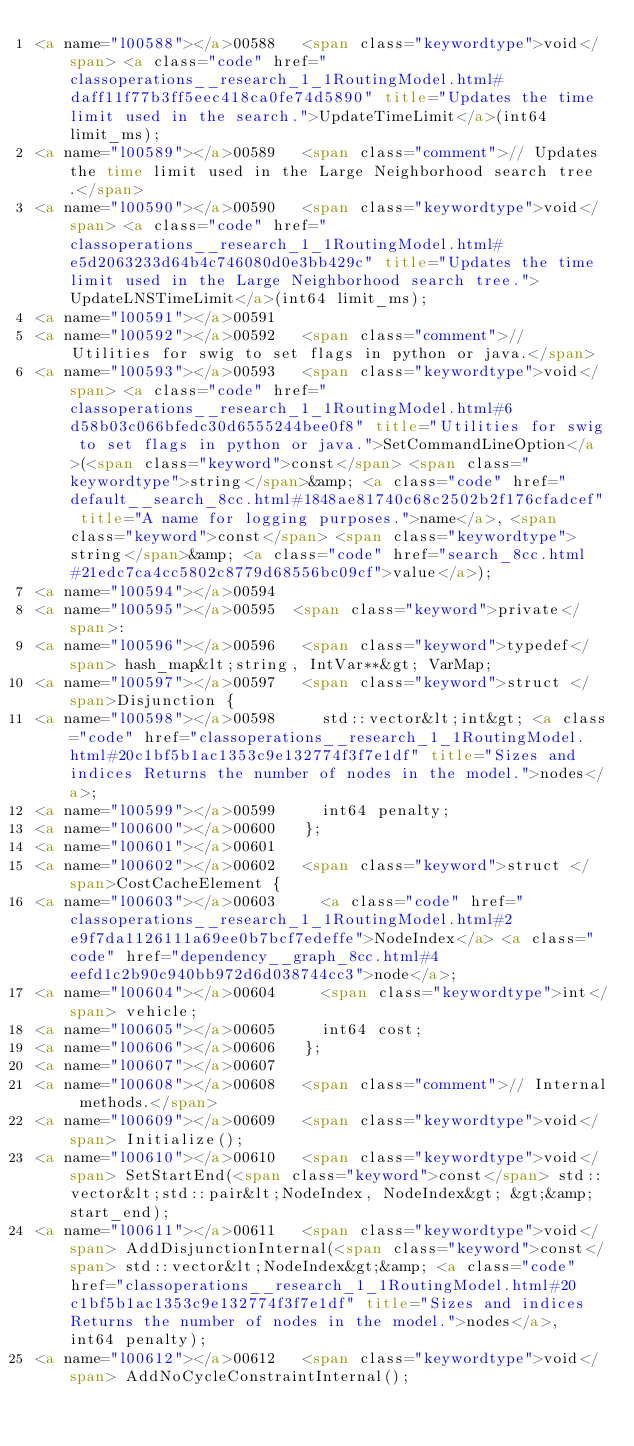Convert code to text. <code><loc_0><loc_0><loc_500><loc_500><_HTML_><a name="l00588"></a>00588   <span class="keywordtype">void</span> <a class="code" href="classoperations__research_1_1RoutingModel.html#daff11f77b3ff5eec418ca0fe74d5890" title="Updates the time limit used in the search.">UpdateTimeLimit</a>(int64 limit_ms);
<a name="l00589"></a>00589   <span class="comment">// Updates the time limit used in the Large Neighborhood search tree.</span>
<a name="l00590"></a>00590   <span class="keywordtype">void</span> <a class="code" href="classoperations__research_1_1RoutingModel.html#e5d2063233d64b4c746080d0e3bb429c" title="Updates the time limit used in the Large Neighborhood search tree.">UpdateLNSTimeLimit</a>(int64 limit_ms);
<a name="l00591"></a>00591 
<a name="l00592"></a>00592   <span class="comment">// Utilities for swig to set flags in python or java.</span>
<a name="l00593"></a>00593   <span class="keywordtype">void</span> <a class="code" href="classoperations__research_1_1RoutingModel.html#6d58b03c066bfedc30d6555244bee0f8" title="Utilities for swig to set flags in python or java.">SetCommandLineOption</a>(<span class="keyword">const</span> <span class="keywordtype">string</span>&amp; <a class="code" href="default__search_8cc.html#1848ae81740c68c2502b2f176cfadcef" title="A name for logging purposes.">name</a>, <span class="keyword">const</span> <span class="keywordtype">string</span>&amp; <a class="code" href="search_8cc.html#21edc7ca4cc5802c8779d68556bc09cf">value</a>);
<a name="l00594"></a>00594 
<a name="l00595"></a>00595  <span class="keyword">private</span>:
<a name="l00596"></a>00596   <span class="keyword">typedef</span> hash_map&lt;string, IntVar**&gt; VarMap;
<a name="l00597"></a>00597   <span class="keyword">struct </span>Disjunction {
<a name="l00598"></a>00598     std::vector&lt;int&gt; <a class="code" href="classoperations__research_1_1RoutingModel.html#20c1bf5b1ac1353c9e132774f3f7e1df" title="Sizes and indices Returns the number of nodes in the model.">nodes</a>;
<a name="l00599"></a>00599     int64 penalty;
<a name="l00600"></a>00600   };
<a name="l00601"></a>00601 
<a name="l00602"></a>00602   <span class="keyword">struct </span>CostCacheElement {
<a name="l00603"></a>00603     <a class="code" href="classoperations__research_1_1RoutingModel.html#2e9f7da1126111a69ee0b7bcf7edeffe">NodeIndex</a> <a class="code" href="dependency__graph_8cc.html#4eefd1c2b90c940bb972d6d038744cc3">node</a>;
<a name="l00604"></a>00604     <span class="keywordtype">int</span> vehicle;
<a name="l00605"></a>00605     int64 cost;
<a name="l00606"></a>00606   };
<a name="l00607"></a>00607 
<a name="l00608"></a>00608   <span class="comment">// Internal methods.</span>
<a name="l00609"></a>00609   <span class="keywordtype">void</span> Initialize();
<a name="l00610"></a>00610   <span class="keywordtype">void</span> SetStartEnd(<span class="keyword">const</span> std::vector&lt;std::pair&lt;NodeIndex, NodeIndex&gt; &gt;&amp; start_end);
<a name="l00611"></a>00611   <span class="keywordtype">void</span> AddDisjunctionInternal(<span class="keyword">const</span> std::vector&lt;NodeIndex&gt;&amp; <a class="code" href="classoperations__research_1_1RoutingModel.html#20c1bf5b1ac1353c9e132774f3f7e1df" title="Sizes and indices Returns the number of nodes in the model.">nodes</a>, int64 penalty);
<a name="l00612"></a>00612   <span class="keywordtype">void</span> AddNoCycleConstraintInternal();</code> 